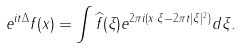Convert formula to latex. <formula><loc_0><loc_0><loc_500><loc_500>e ^ { i t \Delta } f ( x ) = \int \widehat { f } ( \xi ) e ^ { 2 \pi i ( x \cdot \xi - 2 \pi t | \xi | ^ { 2 } ) } d \xi .</formula> 